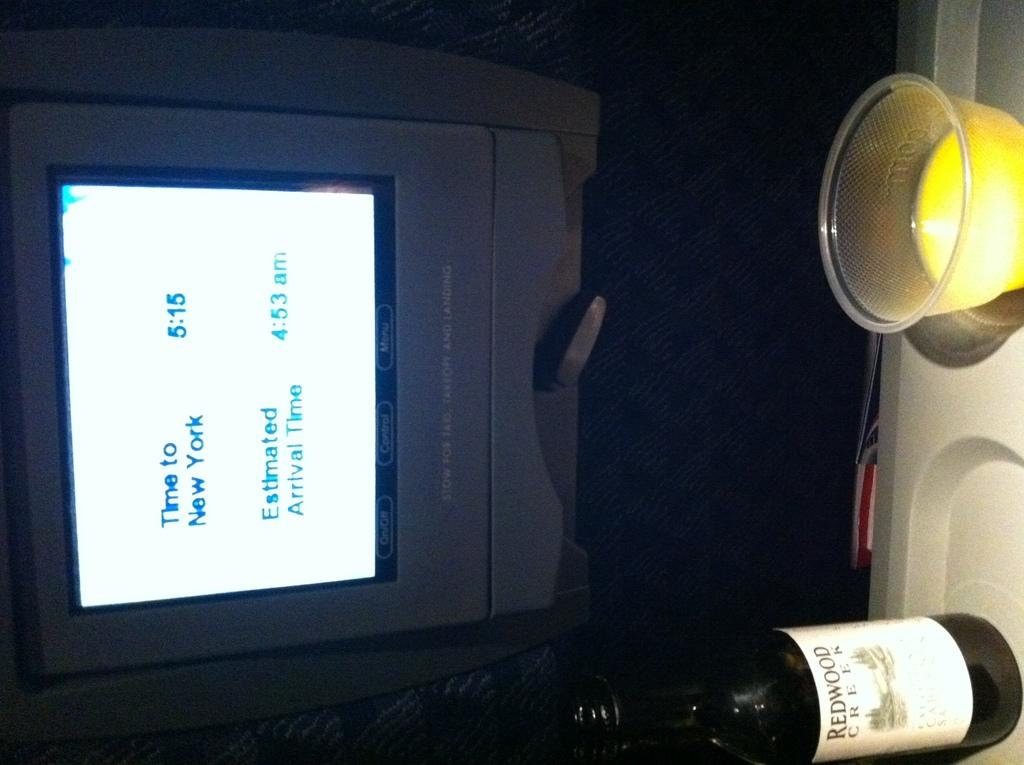Provide a one-sentence caption for the provided image. Screen which shows the time to New York at 5:15. 